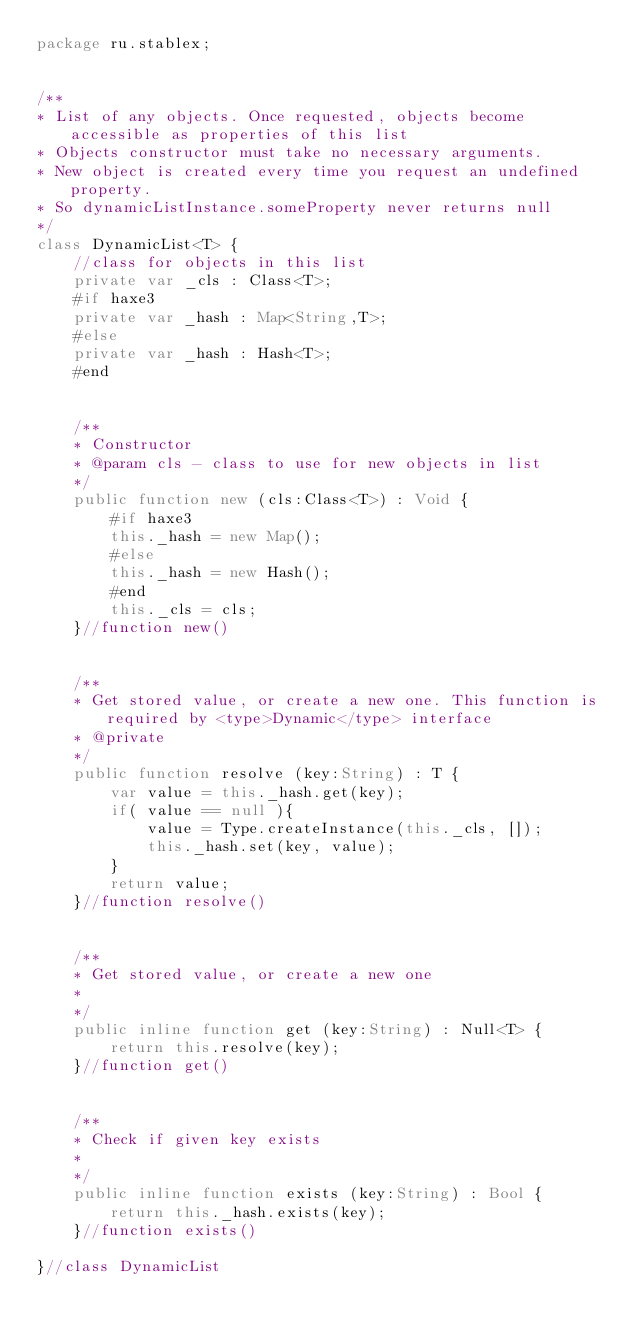Convert code to text. <code><loc_0><loc_0><loc_500><loc_500><_Haxe_>package ru.stablex;


/**
* List of any objects. Once requested, objects become accessible as properties of this list
* Objects constructor must take no necessary arguments.
* New object is created every time you request an undefined property.
* So dynamicListInstance.someProperty never returns null
*/
class DynamicList<T> {
    //class for objects in this list
    private var _cls : Class<T>;
    #if haxe3
    private var _hash : Map<String,T>;
    #else
    private var _hash : Hash<T>;
    #end


    /**
    * Constructor
    * @param cls - class to use for new objects in list
    */
    public function new (cls:Class<T>) : Void {
        #if haxe3
        this._hash = new Map();
        #else
        this._hash = new Hash();
        #end
        this._cls = cls;
    }//function new()


    /**
    * Get stored value, or create a new one. This function is required by <type>Dynamic</type> interface
    * @private
    */
    public function resolve (key:String) : T {
        var value = this._hash.get(key);
        if( value == null ){
            value = Type.createInstance(this._cls, []);
            this._hash.set(key, value);
        }
        return value;
    }//function resolve()


    /**
    * Get stored value, or create a new one
    *
    */
    public inline function get (key:String) : Null<T> {
        return this.resolve(key);
    }//function get()


    /**
    * Check if given key exists
    *
    */
    public inline function exists (key:String) : Bool {
        return this._hash.exists(key);
    }//function exists()

}//class DynamicList
</code> 